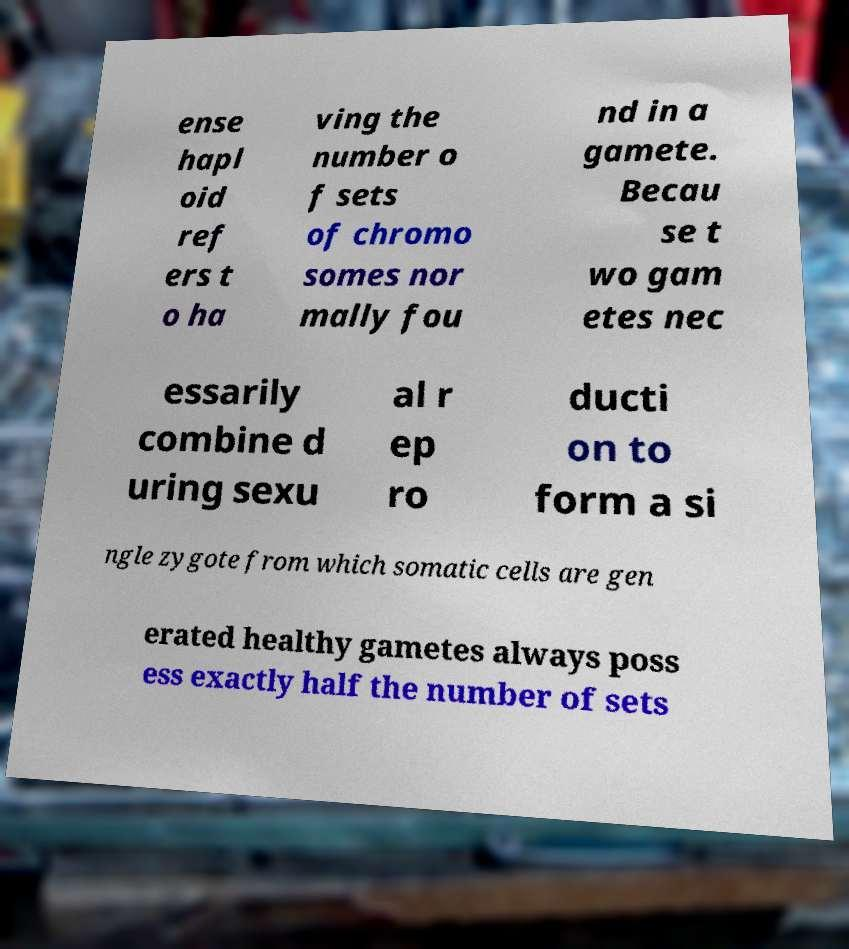Can you accurately transcribe the text from the provided image for me? ense hapl oid ref ers t o ha ving the number o f sets of chromo somes nor mally fou nd in a gamete. Becau se t wo gam etes nec essarily combine d uring sexu al r ep ro ducti on to form a si ngle zygote from which somatic cells are gen erated healthy gametes always poss ess exactly half the number of sets 